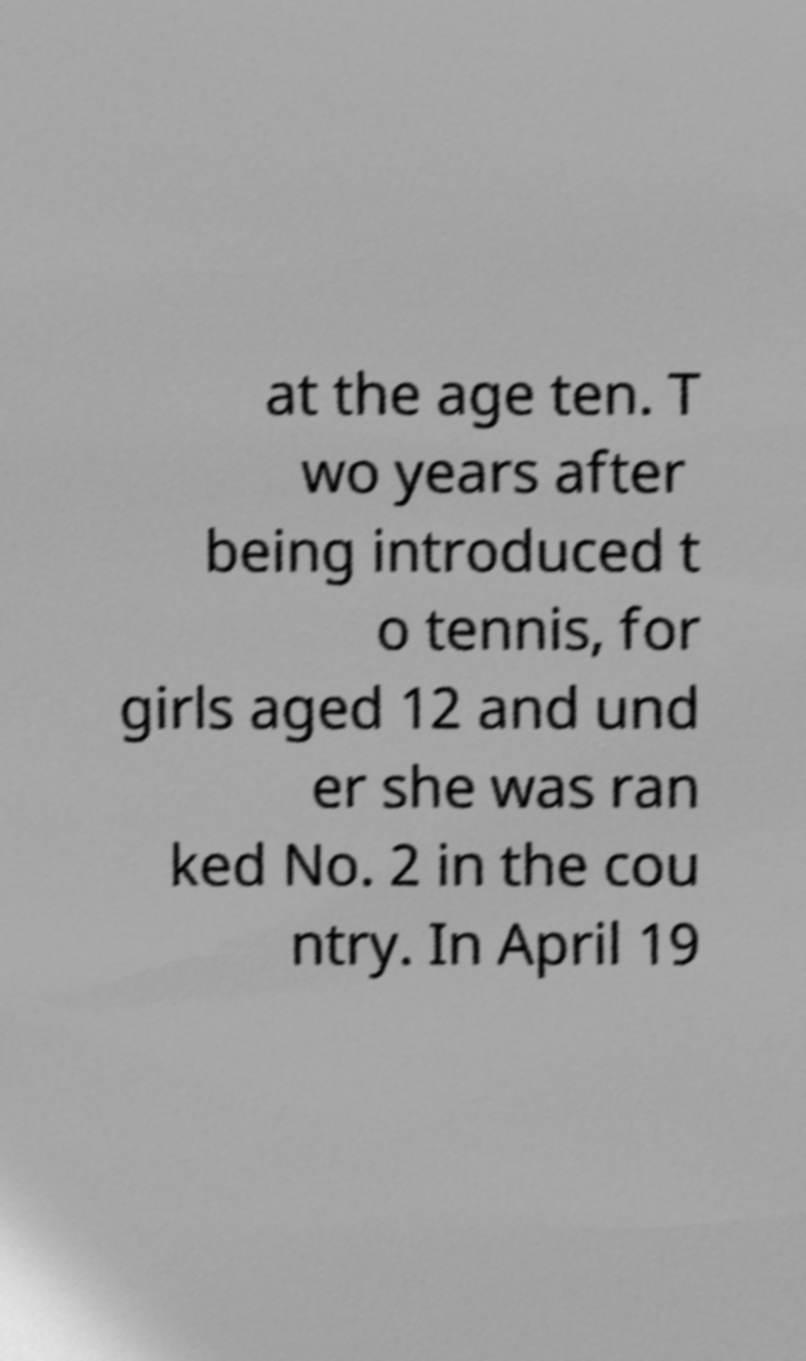Please identify and transcribe the text found in this image. at the age ten. T wo years after being introduced t o tennis, for girls aged 12 and und er she was ran ked No. 2 in the cou ntry. In April 19 